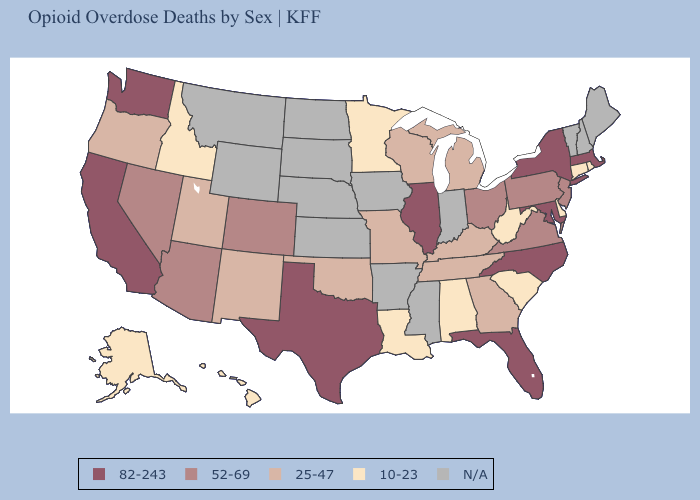Does the map have missing data?
Concise answer only. Yes. Among the states that border Ohio , does Pennsylvania have the lowest value?
Answer briefly. No. How many symbols are there in the legend?
Keep it brief. 5. Among the states that border Colorado , does Arizona have the lowest value?
Keep it brief. No. What is the value of New York?
Write a very short answer. 82-243. Name the states that have a value in the range N/A?
Concise answer only. Arkansas, Indiana, Iowa, Kansas, Maine, Mississippi, Montana, Nebraska, New Hampshire, North Dakota, South Dakota, Vermont, Wyoming. What is the value of Wyoming?
Concise answer only. N/A. Name the states that have a value in the range 10-23?
Quick response, please. Alabama, Alaska, Connecticut, Delaware, Hawaii, Idaho, Louisiana, Minnesota, Rhode Island, South Carolina, West Virginia. Is the legend a continuous bar?
Keep it brief. No. What is the highest value in the USA?
Short answer required. 82-243. Name the states that have a value in the range 25-47?
Write a very short answer. Georgia, Kentucky, Michigan, Missouri, New Mexico, Oklahoma, Oregon, Tennessee, Utah, Wisconsin. What is the highest value in the USA?
Give a very brief answer. 82-243. What is the lowest value in states that border Wisconsin?
Answer briefly. 10-23. What is the value of Alabama?
Concise answer only. 10-23. What is the value of Ohio?
Write a very short answer. 52-69. 